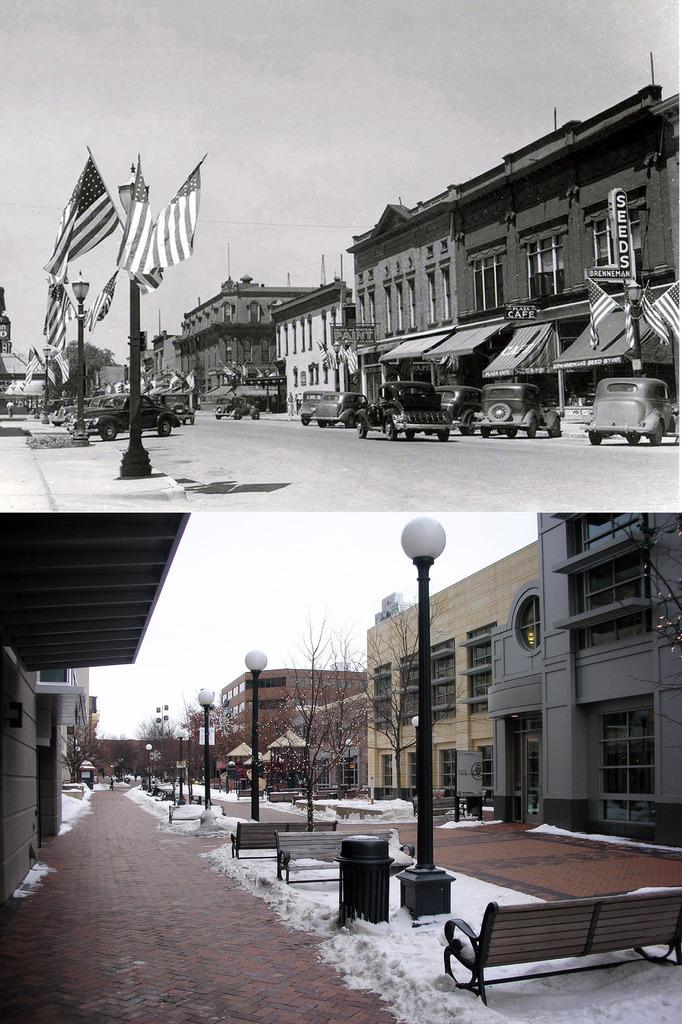What type of artwork is the image? The image is a collage. What part of the natural environment can be seen in the image? Sky, trees, and snow are visible in the image. What man-made structures are present in the image? Light poles, flags, a board, buildings, benches, and a trash can are visible in the image. What is the ground surface like in the image? The ground is visible in the image. What type of straw is being used to build the industry in the image? There is no industry or straw present in the image. Can you describe the man's attire in the image? There is no man present in the image. 